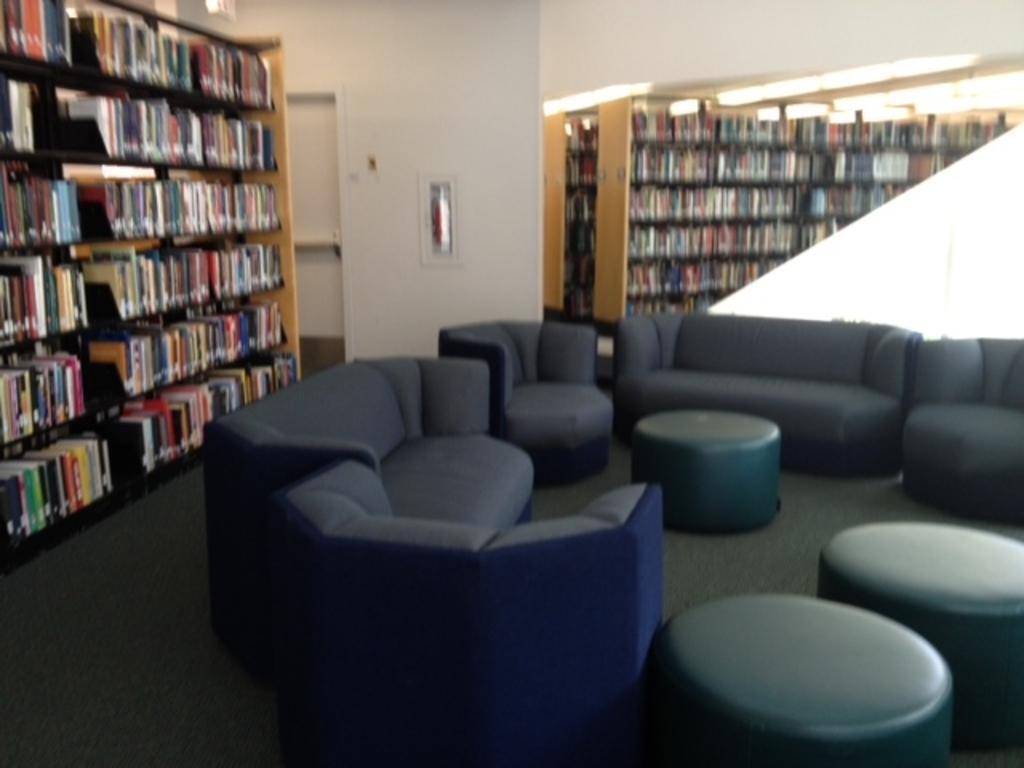In one or two sentences, can you explain what this image depicts? In this here we have big shelf, in the shelf we have books which are kept in same order or line and here we have 2 more shelves one behind the other and in front we have sofa and stools. This seems like a library. 